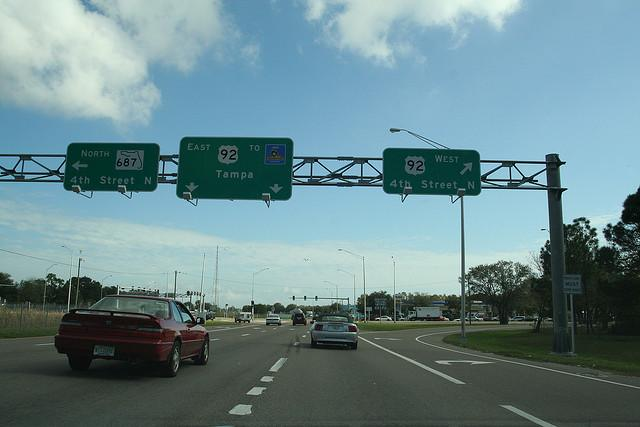What is the right lane used for?

Choices:
A) turns
B) parking
C) racing
D) paying turns 